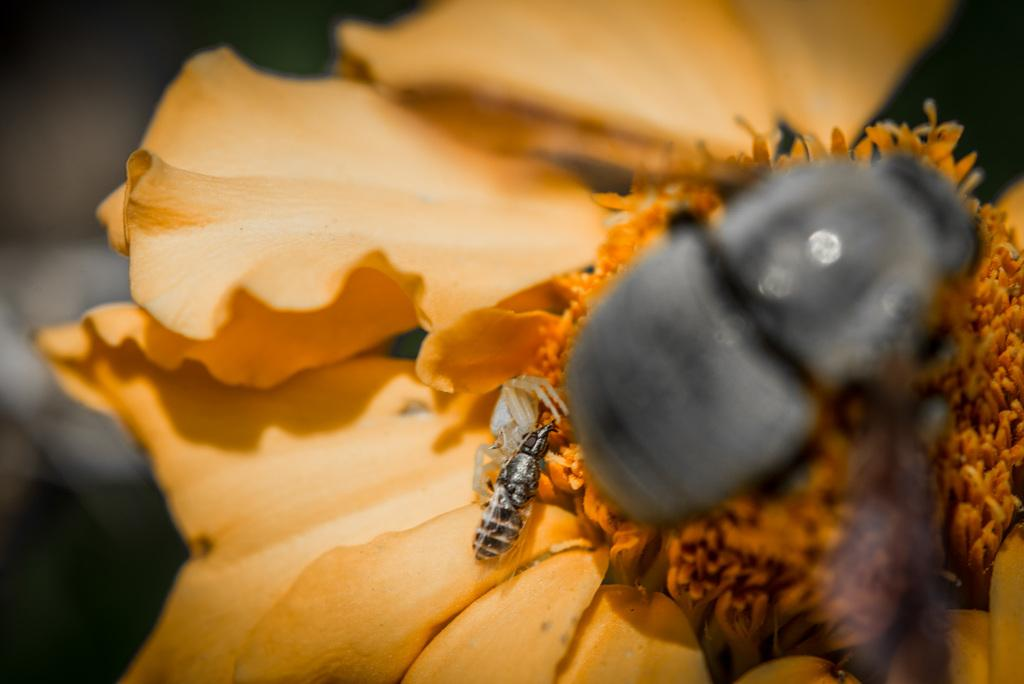What is present on the flower in the image? There is an insect on the flower in the image. Can you describe the insect's location on the flower? The insect is on the flower in the image. What is the insect's selection process for its journey? There is no information about the insect's selection process or journey in the image. 